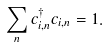<formula> <loc_0><loc_0><loc_500><loc_500>\sum _ { n } c ^ { \dagger } _ { i , n } c _ { i , n } = 1 .</formula> 